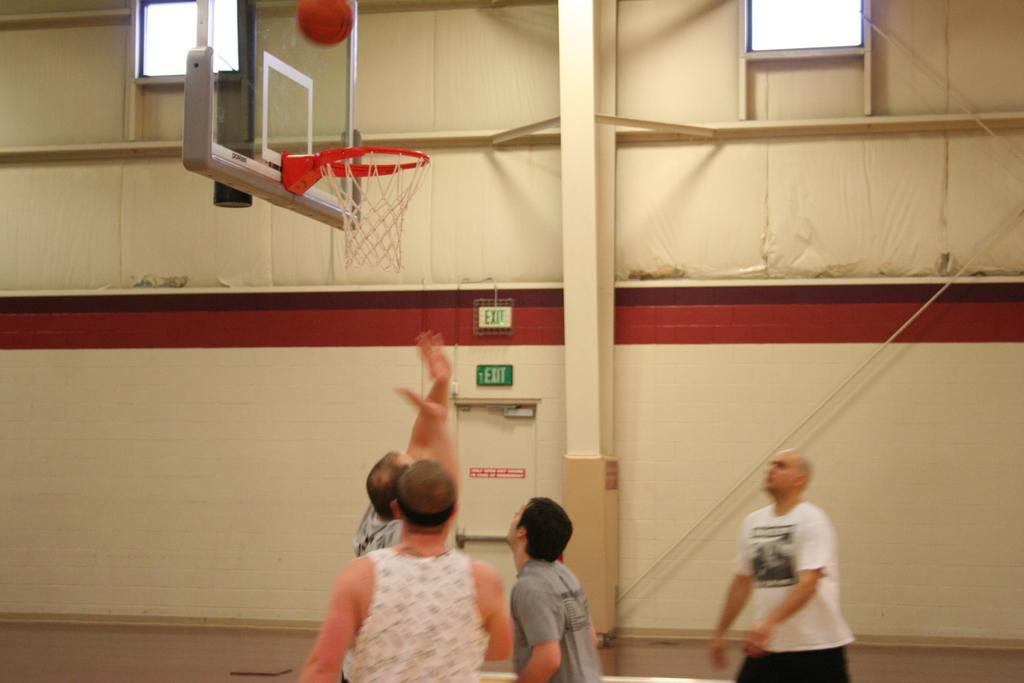In one or two sentences, can you explain what this image depicts? In this picture we can see people playing basketball. Towards left we can see basketball, net and other objects. In the background we can see windows, wall, iron frame, door, boat and other objects. 